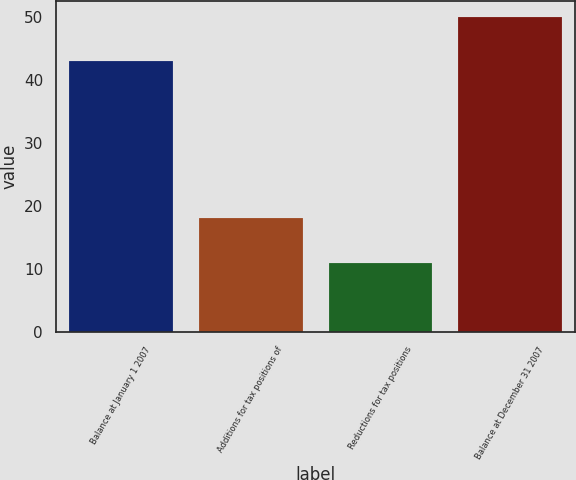<chart> <loc_0><loc_0><loc_500><loc_500><bar_chart><fcel>Balance at January 1 2007<fcel>Additions for tax positions of<fcel>Reductions for tax positions<fcel>Balance at December 31 2007<nl><fcel>43<fcel>18<fcel>11<fcel>50<nl></chart> 